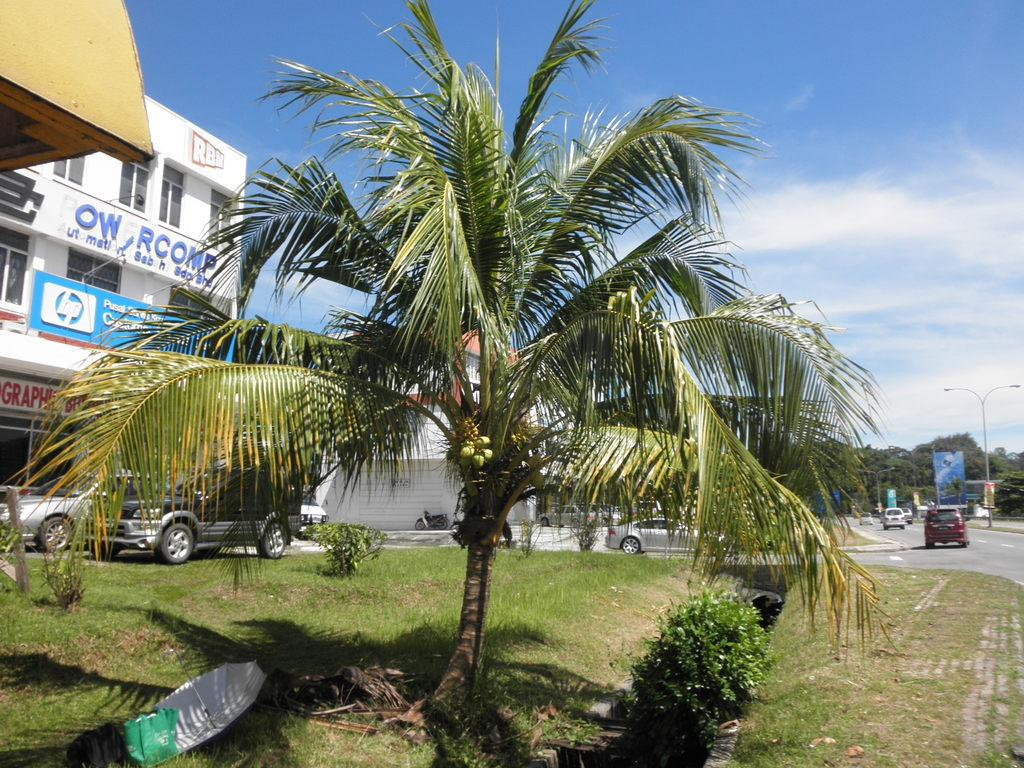What type of structures can be seen in the image? There are buildings in the image. What type of vehicles are on the road in the image? There are cars on the road in the image. What type of vegetation is at the bottom of the image? There are shrubs at the bottom of the image. What type of ground cover is present in the image? There is grass in the image. What type of vegetation can be seen in the background of the image? There are trees in the background of the image. What other object can be seen in the background of the image? There is a pole in the background of the image. What is visible in the background of the image? The sky is visible in the background of the image. How does the sand feel in the image? There is no sand present in the image. What type of brush is used to clean the buildings in the image? There is no brush present in the image, and the buildings do not require cleaning. 